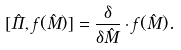<formula> <loc_0><loc_0><loc_500><loc_500>[ \hat { \Pi } , f ( \hat { M } ) ] = \frac { \delta } { \delta \hat { M } } \cdot f ( \hat { M } ) .</formula> 